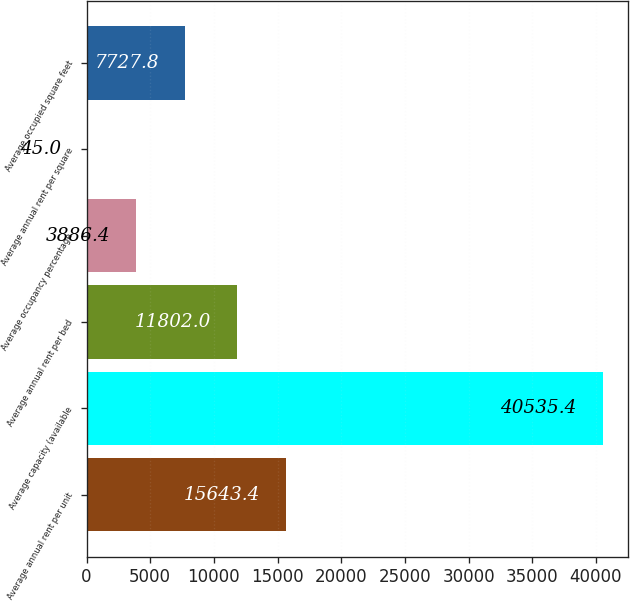Convert chart. <chart><loc_0><loc_0><loc_500><loc_500><bar_chart><fcel>Average annual rent per unit<fcel>Average capacity (available<fcel>Average annual rent per bed<fcel>Average occupancy percentage<fcel>Average annual rent per square<fcel>Average occupied square feet<nl><fcel>15643.4<fcel>40535.4<fcel>11802<fcel>3886.4<fcel>45<fcel>7727.8<nl></chart> 